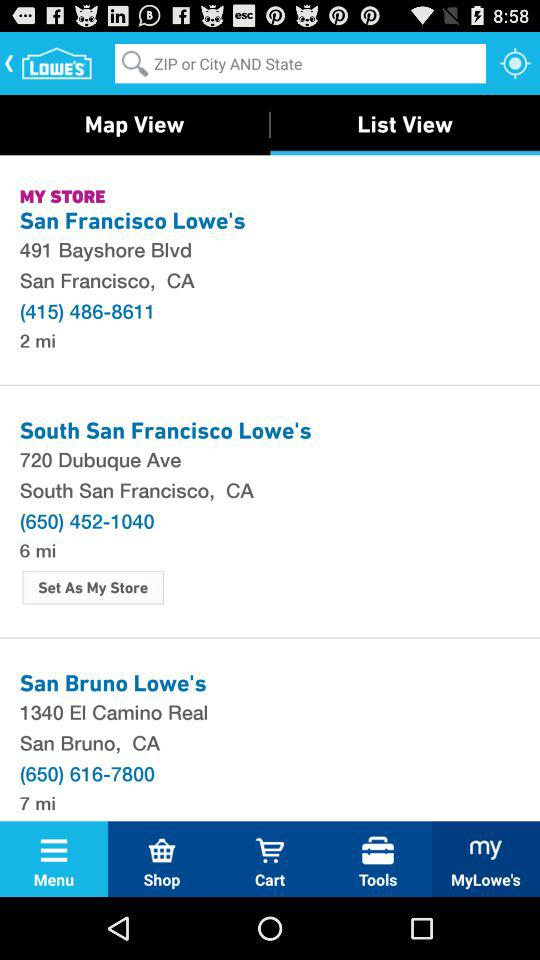Where is the South San Francisco Lowe's located? The location is 720 Dubuque Ave, South San Francisco, CA. 